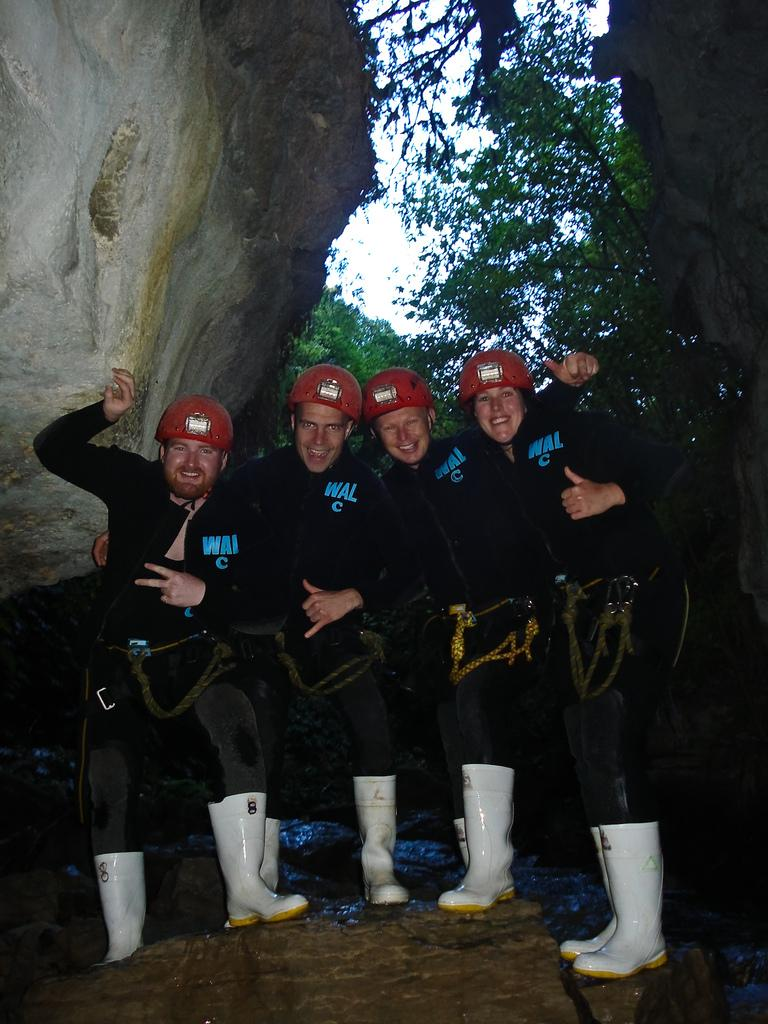How many people are in the image? There are people in the image, but the exact number is not specified. What type of protective gear are the people wearing? The people are wearing helmets and boots. What can be seen in the background of the image? There are trees and the sky visible in the background of the image. What type of terrain is present in the image? There are rocks in the image, suggesting a rocky terrain. What is the opinion of the people in the image about the current political situation? There is no information about the people's opinions or the political situation in the image. 